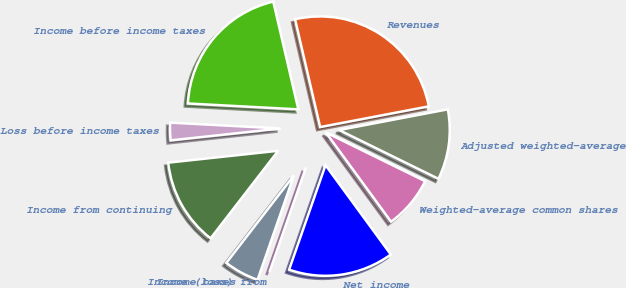Convert chart. <chart><loc_0><loc_0><loc_500><loc_500><pie_chart><fcel>Revenues<fcel>Income before income taxes<fcel>Loss before income taxes<fcel>Income from continuing<fcel>Income taxes<fcel>Income (loss) from<fcel>Net income<fcel>Weighted-average common shares<fcel>Adjusted weighted-average<nl><fcel>25.64%<fcel>20.51%<fcel>2.56%<fcel>12.82%<fcel>5.13%<fcel>0.0%<fcel>15.38%<fcel>7.69%<fcel>10.26%<nl></chart> 